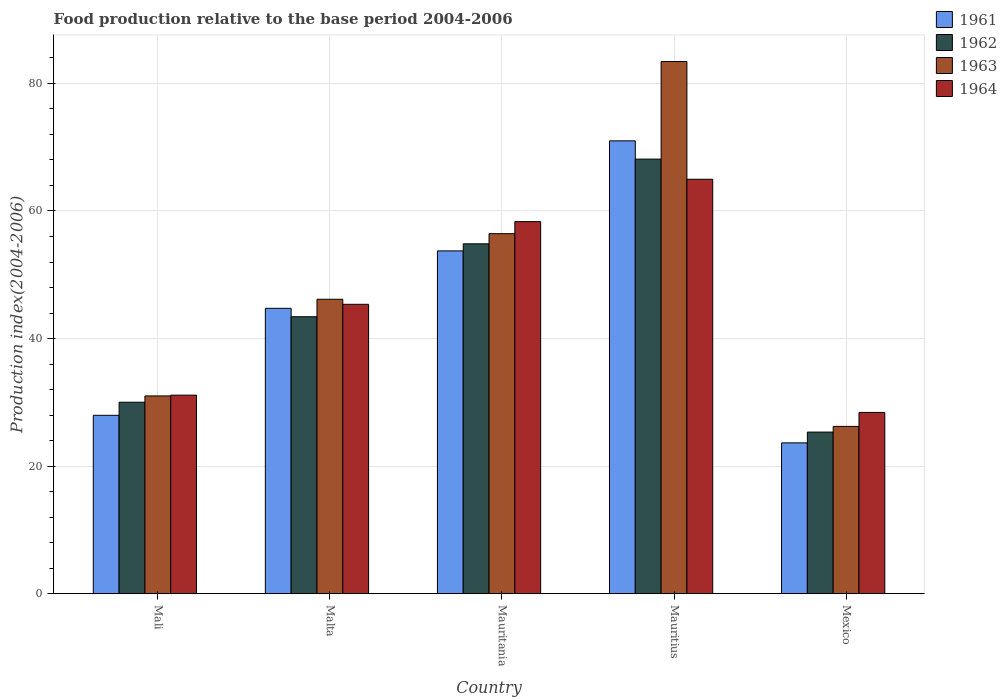Are the number of bars per tick equal to the number of legend labels?
Offer a terse response. Yes. Are the number of bars on each tick of the X-axis equal?
Offer a terse response. Yes. What is the label of the 3rd group of bars from the left?
Provide a short and direct response. Mauritania. What is the food production index in 1961 in Malta?
Provide a succinct answer. 44.74. Across all countries, what is the maximum food production index in 1961?
Your answer should be compact. 70.99. Across all countries, what is the minimum food production index in 1962?
Your answer should be compact. 25.34. In which country was the food production index in 1961 maximum?
Provide a succinct answer. Mauritius. In which country was the food production index in 1964 minimum?
Your response must be concise. Mexico. What is the total food production index in 1964 in the graph?
Ensure brevity in your answer.  228.22. What is the difference between the food production index in 1962 in Mali and that in Malta?
Ensure brevity in your answer.  -13.4. What is the difference between the food production index in 1962 in Mauritania and the food production index in 1964 in Malta?
Make the answer very short. 9.48. What is the average food production index in 1964 per country?
Your response must be concise. 45.64. What is the difference between the food production index of/in 1963 and food production index of/in 1964 in Mauritius?
Give a very brief answer. 18.46. In how many countries, is the food production index in 1964 greater than 8?
Your answer should be very brief. 5. What is the ratio of the food production index in 1961 in Malta to that in Mauritania?
Offer a very short reply. 0.83. Is the food production index in 1964 in Malta less than that in Mauritania?
Make the answer very short. Yes. What is the difference between the highest and the second highest food production index in 1963?
Make the answer very short. -26.99. What is the difference between the highest and the lowest food production index in 1963?
Your answer should be compact. 57.2. Is the sum of the food production index in 1961 in Mali and Mauritius greater than the maximum food production index in 1963 across all countries?
Offer a very short reply. Yes. What does the 4th bar from the left in Malta represents?
Give a very brief answer. 1964. Is it the case that in every country, the sum of the food production index in 1964 and food production index in 1963 is greater than the food production index in 1962?
Provide a succinct answer. Yes. Are all the bars in the graph horizontal?
Your response must be concise. No. How many countries are there in the graph?
Your answer should be very brief. 5. Are the values on the major ticks of Y-axis written in scientific E-notation?
Give a very brief answer. No. Does the graph contain grids?
Give a very brief answer. Yes. Where does the legend appear in the graph?
Offer a very short reply. Top right. How are the legend labels stacked?
Offer a terse response. Vertical. What is the title of the graph?
Offer a very short reply. Food production relative to the base period 2004-2006. Does "1973" appear as one of the legend labels in the graph?
Offer a very short reply. No. What is the label or title of the X-axis?
Give a very brief answer. Country. What is the label or title of the Y-axis?
Provide a succinct answer. Production index(2004-2006). What is the Production index(2004-2006) in 1961 in Mali?
Offer a very short reply. 27.97. What is the Production index(2004-2006) in 1962 in Mali?
Make the answer very short. 30.02. What is the Production index(2004-2006) in 1963 in Mali?
Keep it short and to the point. 31.01. What is the Production index(2004-2006) in 1964 in Mali?
Your answer should be very brief. 31.13. What is the Production index(2004-2006) of 1961 in Malta?
Provide a short and direct response. 44.74. What is the Production index(2004-2006) in 1962 in Malta?
Your answer should be very brief. 43.42. What is the Production index(2004-2006) of 1963 in Malta?
Your answer should be compact. 46.16. What is the Production index(2004-2006) of 1964 in Malta?
Provide a succinct answer. 45.37. What is the Production index(2004-2006) of 1961 in Mauritania?
Your answer should be very brief. 53.74. What is the Production index(2004-2006) of 1962 in Mauritania?
Provide a succinct answer. 54.85. What is the Production index(2004-2006) of 1963 in Mauritania?
Your answer should be compact. 56.44. What is the Production index(2004-2006) in 1964 in Mauritania?
Keep it short and to the point. 58.33. What is the Production index(2004-2006) of 1961 in Mauritius?
Your answer should be compact. 70.99. What is the Production index(2004-2006) of 1962 in Mauritius?
Offer a terse response. 68.13. What is the Production index(2004-2006) of 1963 in Mauritius?
Provide a short and direct response. 83.43. What is the Production index(2004-2006) in 1964 in Mauritius?
Ensure brevity in your answer.  64.97. What is the Production index(2004-2006) of 1961 in Mexico?
Give a very brief answer. 23.65. What is the Production index(2004-2006) in 1962 in Mexico?
Your answer should be compact. 25.34. What is the Production index(2004-2006) of 1963 in Mexico?
Provide a short and direct response. 26.23. What is the Production index(2004-2006) of 1964 in Mexico?
Provide a succinct answer. 28.42. Across all countries, what is the maximum Production index(2004-2006) of 1961?
Offer a very short reply. 70.99. Across all countries, what is the maximum Production index(2004-2006) of 1962?
Ensure brevity in your answer.  68.13. Across all countries, what is the maximum Production index(2004-2006) of 1963?
Offer a terse response. 83.43. Across all countries, what is the maximum Production index(2004-2006) of 1964?
Offer a very short reply. 64.97. Across all countries, what is the minimum Production index(2004-2006) of 1961?
Give a very brief answer. 23.65. Across all countries, what is the minimum Production index(2004-2006) in 1962?
Give a very brief answer. 25.34. Across all countries, what is the minimum Production index(2004-2006) of 1963?
Your answer should be very brief. 26.23. Across all countries, what is the minimum Production index(2004-2006) of 1964?
Your answer should be very brief. 28.42. What is the total Production index(2004-2006) of 1961 in the graph?
Your answer should be compact. 221.09. What is the total Production index(2004-2006) in 1962 in the graph?
Provide a short and direct response. 221.76. What is the total Production index(2004-2006) in 1963 in the graph?
Keep it short and to the point. 243.27. What is the total Production index(2004-2006) in 1964 in the graph?
Make the answer very short. 228.22. What is the difference between the Production index(2004-2006) of 1961 in Mali and that in Malta?
Provide a short and direct response. -16.77. What is the difference between the Production index(2004-2006) in 1963 in Mali and that in Malta?
Provide a succinct answer. -15.15. What is the difference between the Production index(2004-2006) in 1964 in Mali and that in Malta?
Make the answer very short. -14.24. What is the difference between the Production index(2004-2006) in 1961 in Mali and that in Mauritania?
Ensure brevity in your answer.  -25.77. What is the difference between the Production index(2004-2006) in 1962 in Mali and that in Mauritania?
Your answer should be very brief. -24.83. What is the difference between the Production index(2004-2006) of 1963 in Mali and that in Mauritania?
Your answer should be compact. -25.43. What is the difference between the Production index(2004-2006) in 1964 in Mali and that in Mauritania?
Your answer should be compact. -27.2. What is the difference between the Production index(2004-2006) in 1961 in Mali and that in Mauritius?
Your response must be concise. -43.02. What is the difference between the Production index(2004-2006) in 1962 in Mali and that in Mauritius?
Your response must be concise. -38.11. What is the difference between the Production index(2004-2006) in 1963 in Mali and that in Mauritius?
Ensure brevity in your answer.  -52.42. What is the difference between the Production index(2004-2006) of 1964 in Mali and that in Mauritius?
Provide a short and direct response. -33.84. What is the difference between the Production index(2004-2006) of 1961 in Mali and that in Mexico?
Ensure brevity in your answer.  4.32. What is the difference between the Production index(2004-2006) of 1962 in Mali and that in Mexico?
Your answer should be compact. 4.68. What is the difference between the Production index(2004-2006) in 1963 in Mali and that in Mexico?
Your response must be concise. 4.78. What is the difference between the Production index(2004-2006) in 1964 in Mali and that in Mexico?
Keep it short and to the point. 2.71. What is the difference between the Production index(2004-2006) in 1961 in Malta and that in Mauritania?
Provide a short and direct response. -9. What is the difference between the Production index(2004-2006) of 1962 in Malta and that in Mauritania?
Ensure brevity in your answer.  -11.43. What is the difference between the Production index(2004-2006) in 1963 in Malta and that in Mauritania?
Keep it short and to the point. -10.28. What is the difference between the Production index(2004-2006) in 1964 in Malta and that in Mauritania?
Give a very brief answer. -12.96. What is the difference between the Production index(2004-2006) of 1961 in Malta and that in Mauritius?
Your answer should be very brief. -26.25. What is the difference between the Production index(2004-2006) of 1962 in Malta and that in Mauritius?
Your answer should be very brief. -24.71. What is the difference between the Production index(2004-2006) of 1963 in Malta and that in Mauritius?
Your answer should be compact. -37.27. What is the difference between the Production index(2004-2006) of 1964 in Malta and that in Mauritius?
Your answer should be very brief. -19.6. What is the difference between the Production index(2004-2006) in 1961 in Malta and that in Mexico?
Offer a terse response. 21.09. What is the difference between the Production index(2004-2006) of 1962 in Malta and that in Mexico?
Make the answer very short. 18.08. What is the difference between the Production index(2004-2006) in 1963 in Malta and that in Mexico?
Provide a short and direct response. 19.93. What is the difference between the Production index(2004-2006) in 1964 in Malta and that in Mexico?
Your response must be concise. 16.95. What is the difference between the Production index(2004-2006) of 1961 in Mauritania and that in Mauritius?
Provide a short and direct response. -17.25. What is the difference between the Production index(2004-2006) in 1962 in Mauritania and that in Mauritius?
Offer a very short reply. -13.28. What is the difference between the Production index(2004-2006) in 1963 in Mauritania and that in Mauritius?
Make the answer very short. -26.99. What is the difference between the Production index(2004-2006) of 1964 in Mauritania and that in Mauritius?
Your response must be concise. -6.64. What is the difference between the Production index(2004-2006) in 1961 in Mauritania and that in Mexico?
Make the answer very short. 30.09. What is the difference between the Production index(2004-2006) in 1962 in Mauritania and that in Mexico?
Provide a short and direct response. 29.51. What is the difference between the Production index(2004-2006) of 1963 in Mauritania and that in Mexico?
Provide a succinct answer. 30.21. What is the difference between the Production index(2004-2006) of 1964 in Mauritania and that in Mexico?
Your answer should be very brief. 29.91. What is the difference between the Production index(2004-2006) in 1961 in Mauritius and that in Mexico?
Your answer should be compact. 47.34. What is the difference between the Production index(2004-2006) in 1962 in Mauritius and that in Mexico?
Ensure brevity in your answer.  42.79. What is the difference between the Production index(2004-2006) in 1963 in Mauritius and that in Mexico?
Provide a short and direct response. 57.2. What is the difference between the Production index(2004-2006) in 1964 in Mauritius and that in Mexico?
Your response must be concise. 36.55. What is the difference between the Production index(2004-2006) of 1961 in Mali and the Production index(2004-2006) of 1962 in Malta?
Your answer should be very brief. -15.45. What is the difference between the Production index(2004-2006) in 1961 in Mali and the Production index(2004-2006) in 1963 in Malta?
Ensure brevity in your answer.  -18.19. What is the difference between the Production index(2004-2006) of 1961 in Mali and the Production index(2004-2006) of 1964 in Malta?
Give a very brief answer. -17.4. What is the difference between the Production index(2004-2006) of 1962 in Mali and the Production index(2004-2006) of 1963 in Malta?
Your answer should be very brief. -16.14. What is the difference between the Production index(2004-2006) in 1962 in Mali and the Production index(2004-2006) in 1964 in Malta?
Your answer should be very brief. -15.35. What is the difference between the Production index(2004-2006) in 1963 in Mali and the Production index(2004-2006) in 1964 in Malta?
Ensure brevity in your answer.  -14.36. What is the difference between the Production index(2004-2006) of 1961 in Mali and the Production index(2004-2006) of 1962 in Mauritania?
Your answer should be compact. -26.88. What is the difference between the Production index(2004-2006) of 1961 in Mali and the Production index(2004-2006) of 1963 in Mauritania?
Your answer should be compact. -28.47. What is the difference between the Production index(2004-2006) in 1961 in Mali and the Production index(2004-2006) in 1964 in Mauritania?
Your answer should be compact. -30.36. What is the difference between the Production index(2004-2006) in 1962 in Mali and the Production index(2004-2006) in 1963 in Mauritania?
Make the answer very short. -26.42. What is the difference between the Production index(2004-2006) of 1962 in Mali and the Production index(2004-2006) of 1964 in Mauritania?
Keep it short and to the point. -28.31. What is the difference between the Production index(2004-2006) in 1963 in Mali and the Production index(2004-2006) in 1964 in Mauritania?
Provide a short and direct response. -27.32. What is the difference between the Production index(2004-2006) in 1961 in Mali and the Production index(2004-2006) in 1962 in Mauritius?
Offer a very short reply. -40.16. What is the difference between the Production index(2004-2006) in 1961 in Mali and the Production index(2004-2006) in 1963 in Mauritius?
Give a very brief answer. -55.46. What is the difference between the Production index(2004-2006) in 1961 in Mali and the Production index(2004-2006) in 1964 in Mauritius?
Keep it short and to the point. -37. What is the difference between the Production index(2004-2006) of 1962 in Mali and the Production index(2004-2006) of 1963 in Mauritius?
Offer a very short reply. -53.41. What is the difference between the Production index(2004-2006) of 1962 in Mali and the Production index(2004-2006) of 1964 in Mauritius?
Offer a terse response. -34.95. What is the difference between the Production index(2004-2006) in 1963 in Mali and the Production index(2004-2006) in 1964 in Mauritius?
Your answer should be very brief. -33.96. What is the difference between the Production index(2004-2006) of 1961 in Mali and the Production index(2004-2006) of 1962 in Mexico?
Your response must be concise. 2.63. What is the difference between the Production index(2004-2006) in 1961 in Mali and the Production index(2004-2006) in 1963 in Mexico?
Keep it short and to the point. 1.74. What is the difference between the Production index(2004-2006) in 1961 in Mali and the Production index(2004-2006) in 1964 in Mexico?
Your response must be concise. -0.45. What is the difference between the Production index(2004-2006) of 1962 in Mali and the Production index(2004-2006) of 1963 in Mexico?
Offer a terse response. 3.79. What is the difference between the Production index(2004-2006) in 1962 in Mali and the Production index(2004-2006) in 1964 in Mexico?
Offer a terse response. 1.6. What is the difference between the Production index(2004-2006) of 1963 in Mali and the Production index(2004-2006) of 1964 in Mexico?
Your answer should be compact. 2.59. What is the difference between the Production index(2004-2006) in 1961 in Malta and the Production index(2004-2006) in 1962 in Mauritania?
Keep it short and to the point. -10.11. What is the difference between the Production index(2004-2006) of 1961 in Malta and the Production index(2004-2006) of 1964 in Mauritania?
Offer a terse response. -13.59. What is the difference between the Production index(2004-2006) of 1962 in Malta and the Production index(2004-2006) of 1963 in Mauritania?
Your response must be concise. -13.02. What is the difference between the Production index(2004-2006) of 1962 in Malta and the Production index(2004-2006) of 1964 in Mauritania?
Keep it short and to the point. -14.91. What is the difference between the Production index(2004-2006) in 1963 in Malta and the Production index(2004-2006) in 1964 in Mauritania?
Provide a succinct answer. -12.17. What is the difference between the Production index(2004-2006) in 1961 in Malta and the Production index(2004-2006) in 1962 in Mauritius?
Provide a succinct answer. -23.39. What is the difference between the Production index(2004-2006) in 1961 in Malta and the Production index(2004-2006) in 1963 in Mauritius?
Provide a short and direct response. -38.69. What is the difference between the Production index(2004-2006) of 1961 in Malta and the Production index(2004-2006) of 1964 in Mauritius?
Keep it short and to the point. -20.23. What is the difference between the Production index(2004-2006) of 1962 in Malta and the Production index(2004-2006) of 1963 in Mauritius?
Make the answer very short. -40.01. What is the difference between the Production index(2004-2006) in 1962 in Malta and the Production index(2004-2006) in 1964 in Mauritius?
Offer a very short reply. -21.55. What is the difference between the Production index(2004-2006) in 1963 in Malta and the Production index(2004-2006) in 1964 in Mauritius?
Your response must be concise. -18.81. What is the difference between the Production index(2004-2006) in 1961 in Malta and the Production index(2004-2006) in 1962 in Mexico?
Provide a succinct answer. 19.4. What is the difference between the Production index(2004-2006) of 1961 in Malta and the Production index(2004-2006) of 1963 in Mexico?
Ensure brevity in your answer.  18.51. What is the difference between the Production index(2004-2006) in 1961 in Malta and the Production index(2004-2006) in 1964 in Mexico?
Your response must be concise. 16.32. What is the difference between the Production index(2004-2006) of 1962 in Malta and the Production index(2004-2006) of 1963 in Mexico?
Ensure brevity in your answer.  17.19. What is the difference between the Production index(2004-2006) of 1963 in Malta and the Production index(2004-2006) of 1964 in Mexico?
Provide a succinct answer. 17.74. What is the difference between the Production index(2004-2006) of 1961 in Mauritania and the Production index(2004-2006) of 1962 in Mauritius?
Your answer should be compact. -14.39. What is the difference between the Production index(2004-2006) of 1961 in Mauritania and the Production index(2004-2006) of 1963 in Mauritius?
Provide a succinct answer. -29.69. What is the difference between the Production index(2004-2006) in 1961 in Mauritania and the Production index(2004-2006) in 1964 in Mauritius?
Your response must be concise. -11.23. What is the difference between the Production index(2004-2006) in 1962 in Mauritania and the Production index(2004-2006) in 1963 in Mauritius?
Your answer should be compact. -28.58. What is the difference between the Production index(2004-2006) of 1962 in Mauritania and the Production index(2004-2006) of 1964 in Mauritius?
Provide a short and direct response. -10.12. What is the difference between the Production index(2004-2006) of 1963 in Mauritania and the Production index(2004-2006) of 1964 in Mauritius?
Provide a succinct answer. -8.53. What is the difference between the Production index(2004-2006) of 1961 in Mauritania and the Production index(2004-2006) of 1962 in Mexico?
Your answer should be compact. 28.4. What is the difference between the Production index(2004-2006) of 1961 in Mauritania and the Production index(2004-2006) of 1963 in Mexico?
Ensure brevity in your answer.  27.51. What is the difference between the Production index(2004-2006) in 1961 in Mauritania and the Production index(2004-2006) in 1964 in Mexico?
Offer a terse response. 25.32. What is the difference between the Production index(2004-2006) of 1962 in Mauritania and the Production index(2004-2006) of 1963 in Mexico?
Ensure brevity in your answer.  28.62. What is the difference between the Production index(2004-2006) in 1962 in Mauritania and the Production index(2004-2006) in 1964 in Mexico?
Your answer should be very brief. 26.43. What is the difference between the Production index(2004-2006) of 1963 in Mauritania and the Production index(2004-2006) of 1964 in Mexico?
Offer a very short reply. 28.02. What is the difference between the Production index(2004-2006) of 1961 in Mauritius and the Production index(2004-2006) of 1962 in Mexico?
Your answer should be very brief. 45.65. What is the difference between the Production index(2004-2006) in 1961 in Mauritius and the Production index(2004-2006) in 1963 in Mexico?
Your answer should be compact. 44.76. What is the difference between the Production index(2004-2006) of 1961 in Mauritius and the Production index(2004-2006) of 1964 in Mexico?
Offer a very short reply. 42.57. What is the difference between the Production index(2004-2006) in 1962 in Mauritius and the Production index(2004-2006) in 1963 in Mexico?
Keep it short and to the point. 41.9. What is the difference between the Production index(2004-2006) in 1962 in Mauritius and the Production index(2004-2006) in 1964 in Mexico?
Ensure brevity in your answer.  39.71. What is the difference between the Production index(2004-2006) in 1963 in Mauritius and the Production index(2004-2006) in 1964 in Mexico?
Provide a succinct answer. 55.01. What is the average Production index(2004-2006) in 1961 per country?
Ensure brevity in your answer.  44.22. What is the average Production index(2004-2006) in 1962 per country?
Provide a succinct answer. 44.35. What is the average Production index(2004-2006) of 1963 per country?
Give a very brief answer. 48.65. What is the average Production index(2004-2006) in 1964 per country?
Offer a very short reply. 45.64. What is the difference between the Production index(2004-2006) of 1961 and Production index(2004-2006) of 1962 in Mali?
Offer a terse response. -2.05. What is the difference between the Production index(2004-2006) in 1961 and Production index(2004-2006) in 1963 in Mali?
Make the answer very short. -3.04. What is the difference between the Production index(2004-2006) in 1961 and Production index(2004-2006) in 1964 in Mali?
Ensure brevity in your answer.  -3.16. What is the difference between the Production index(2004-2006) in 1962 and Production index(2004-2006) in 1963 in Mali?
Your answer should be compact. -0.99. What is the difference between the Production index(2004-2006) of 1962 and Production index(2004-2006) of 1964 in Mali?
Your answer should be compact. -1.11. What is the difference between the Production index(2004-2006) of 1963 and Production index(2004-2006) of 1964 in Mali?
Your response must be concise. -0.12. What is the difference between the Production index(2004-2006) of 1961 and Production index(2004-2006) of 1962 in Malta?
Offer a very short reply. 1.32. What is the difference between the Production index(2004-2006) of 1961 and Production index(2004-2006) of 1963 in Malta?
Give a very brief answer. -1.42. What is the difference between the Production index(2004-2006) of 1961 and Production index(2004-2006) of 1964 in Malta?
Your answer should be very brief. -0.63. What is the difference between the Production index(2004-2006) of 1962 and Production index(2004-2006) of 1963 in Malta?
Offer a terse response. -2.74. What is the difference between the Production index(2004-2006) of 1962 and Production index(2004-2006) of 1964 in Malta?
Your response must be concise. -1.95. What is the difference between the Production index(2004-2006) of 1963 and Production index(2004-2006) of 1964 in Malta?
Provide a succinct answer. 0.79. What is the difference between the Production index(2004-2006) in 1961 and Production index(2004-2006) in 1962 in Mauritania?
Make the answer very short. -1.11. What is the difference between the Production index(2004-2006) in 1961 and Production index(2004-2006) in 1964 in Mauritania?
Make the answer very short. -4.59. What is the difference between the Production index(2004-2006) in 1962 and Production index(2004-2006) in 1963 in Mauritania?
Provide a short and direct response. -1.59. What is the difference between the Production index(2004-2006) of 1962 and Production index(2004-2006) of 1964 in Mauritania?
Offer a very short reply. -3.48. What is the difference between the Production index(2004-2006) of 1963 and Production index(2004-2006) of 1964 in Mauritania?
Provide a short and direct response. -1.89. What is the difference between the Production index(2004-2006) in 1961 and Production index(2004-2006) in 1962 in Mauritius?
Provide a succinct answer. 2.86. What is the difference between the Production index(2004-2006) in 1961 and Production index(2004-2006) in 1963 in Mauritius?
Provide a short and direct response. -12.44. What is the difference between the Production index(2004-2006) in 1961 and Production index(2004-2006) in 1964 in Mauritius?
Your answer should be very brief. 6.02. What is the difference between the Production index(2004-2006) of 1962 and Production index(2004-2006) of 1963 in Mauritius?
Offer a very short reply. -15.3. What is the difference between the Production index(2004-2006) in 1962 and Production index(2004-2006) in 1964 in Mauritius?
Ensure brevity in your answer.  3.16. What is the difference between the Production index(2004-2006) of 1963 and Production index(2004-2006) of 1964 in Mauritius?
Provide a succinct answer. 18.46. What is the difference between the Production index(2004-2006) of 1961 and Production index(2004-2006) of 1962 in Mexico?
Ensure brevity in your answer.  -1.69. What is the difference between the Production index(2004-2006) of 1961 and Production index(2004-2006) of 1963 in Mexico?
Keep it short and to the point. -2.58. What is the difference between the Production index(2004-2006) in 1961 and Production index(2004-2006) in 1964 in Mexico?
Offer a terse response. -4.77. What is the difference between the Production index(2004-2006) in 1962 and Production index(2004-2006) in 1963 in Mexico?
Make the answer very short. -0.89. What is the difference between the Production index(2004-2006) in 1962 and Production index(2004-2006) in 1964 in Mexico?
Your answer should be very brief. -3.08. What is the difference between the Production index(2004-2006) of 1963 and Production index(2004-2006) of 1964 in Mexico?
Provide a succinct answer. -2.19. What is the ratio of the Production index(2004-2006) in 1961 in Mali to that in Malta?
Your response must be concise. 0.63. What is the ratio of the Production index(2004-2006) in 1962 in Mali to that in Malta?
Offer a very short reply. 0.69. What is the ratio of the Production index(2004-2006) of 1963 in Mali to that in Malta?
Provide a short and direct response. 0.67. What is the ratio of the Production index(2004-2006) in 1964 in Mali to that in Malta?
Provide a short and direct response. 0.69. What is the ratio of the Production index(2004-2006) of 1961 in Mali to that in Mauritania?
Make the answer very short. 0.52. What is the ratio of the Production index(2004-2006) in 1962 in Mali to that in Mauritania?
Keep it short and to the point. 0.55. What is the ratio of the Production index(2004-2006) in 1963 in Mali to that in Mauritania?
Ensure brevity in your answer.  0.55. What is the ratio of the Production index(2004-2006) of 1964 in Mali to that in Mauritania?
Your answer should be compact. 0.53. What is the ratio of the Production index(2004-2006) of 1961 in Mali to that in Mauritius?
Your answer should be compact. 0.39. What is the ratio of the Production index(2004-2006) in 1962 in Mali to that in Mauritius?
Provide a short and direct response. 0.44. What is the ratio of the Production index(2004-2006) in 1963 in Mali to that in Mauritius?
Keep it short and to the point. 0.37. What is the ratio of the Production index(2004-2006) in 1964 in Mali to that in Mauritius?
Your answer should be compact. 0.48. What is the ratio of the Production index(2004-2006) of 1961 in Mali to that in Mexico?
Your answer should be compact. 1.18. What is the ratio of the Production index(2004-2006) of 1962 in Mali to that in Mexico?
Provide a succinct answer. 1.18. What is the ratio of the Production index(2004-2006) in 1963 in Mali to that in Mexico?
Make the answer very short. 1.18. What is the ratio of the Production index(2004-2006) of 1964 in Mali to that in Mexico?
Your answer should be very brief. 1.1. What is the ratio of the Production index(2004-2006) of 1961 in Malta to that in Mauritania?
Provide a succinct answer. 0.83. What is the ratio of the Production index(2004-2006) in 1962 in Malta to that in Mauritania?
Your answer should be very brief. 0.79. What is the ratio of the Production index(2004-2006) of 1963 in Malta to that in Mauritania?
Ensure brevity in your answer.  0.82. What is the ratio of the Production index(2004-2006) in 1961 in Malta to that in Mauritius?
Ensure brevity in your answer.  0.63. What is the ratio of the Production index(2004-2006) of 1962 in Malta to that in Mauritius?
Offer a terse response. 0.64. What is the ratio of the Production index(2004-2006) of 1963 in Malta to that in Mauritius?
Your answer should be compact. 0.55. What is the ratio of the Production index(2004-2006) of 1964 in Malta to that in Mauritius?
Your response must be concise. 0.7. What is the ratio of the Production index(2004-2006) in 1961 in Malta to that in Mexico?
Ensure brevity in your answer.  1.89. What is the ratio of the Production index(2004-2006) in 1962 in Malta to that in Mexico?
Offer a terse response. 1.71. What is the ratio of the Production index(2004-2006) in 1963 in Malta to that in Mexico?
Make the answer very short. 1.76. What is the ratio of the Production index(2004-2006) in 1964 in Malta to that in Mexico?
Keep it short and to the point. 1.6. What is the ratio of the Production index(2004-2006) of 1961 in Mauritania to that in Mauritius?
Provide a succinct answer. 0.76. What is the ratio of the Production index(2004-2006) of 1962 in Mauritania to that in Mauritius?
Keep it short and to the point. 0.81. What is the ratio of the Production index(2004-2006) in 1963 in Mauritania to that in Mauritius?
Make the answer very short. 0.68. What is the ratio of the Production index(2004-2006) in 1964 in Mauritania to that in Mauritius?
Your answer should be very brief. 0.9. What is the ratio of the Production index(2004-2006) of 1961 in Mauritania to that in Mexico?
Keep it short and to the point. 2.27. What is the ratio of the Production index(2004-2006) of 1962 in Mauritania to that in Mexico?
Make the answer very short. 2.16. What is the ratio of the Production index(2004-2006) of 1963 in Mauritania to that in Mexico?
Your answer should be very brief. 2.15. What is the ratio of the Production index(2004-2006) of 1964 in Mauritania to that in Mexico?
Make the answer very short. 2.05. What is the ratio of the Production index(2004-2006) of 1961 in Mauritius to that in Mexico?
Provide a succinct answer. 3. What is the ratio of the Production index(2004-2006) in 1962 in Mauritius to that in Mexico?
Your response must be concise. 2.69. What is the ratio of the Production index(2004-2006) of 1963 in Mauritius to that in Mexico?
Give a very brief answer. 3.18. What is the ratio of the Production index(2004-2006) of 1964 in Mauritius to that in Mexico?
Provide a short and direct response. 2.29. What is the difference between the highest and the second highest Production index(2004-2006) in 1961?
Your answer should be compact. 17.25. What is the difference between the highest and the second highest Production index(2004-2006) of 1962?
Provide a short and direct response. 13.28. What is the difference between the highest and the second highest Production index(2004-2006) of 1963?
Provide a succinct answer. 26.99. What is the difference between the highest and the second highest Production index(2004-2006) of 1964?
Give a very brief answer. 6.64. What is the difference between the highest and the lowest Production index(2004-2006) of 1961?
Provide a succinct answer. 47.34. What is the difference between the highest and the lowest Production index(2004-2006) of 1962?
Ensure brevity in your answer.  42.79. What is the difference between the highest and the lowest Production index(2004-2006) of 1963?
Ensure brevity in your answer.  57.2. What is the difference between the highest and the lowest Production index(2004-2006) of 1964?
Your answer should be compact. 36.55. 